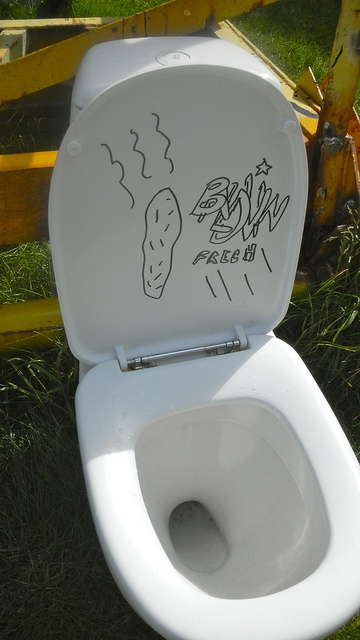Describe the objects in this image and their specific colors. I can see a toilet in darkgray, black, white, and gray tones in this image. 